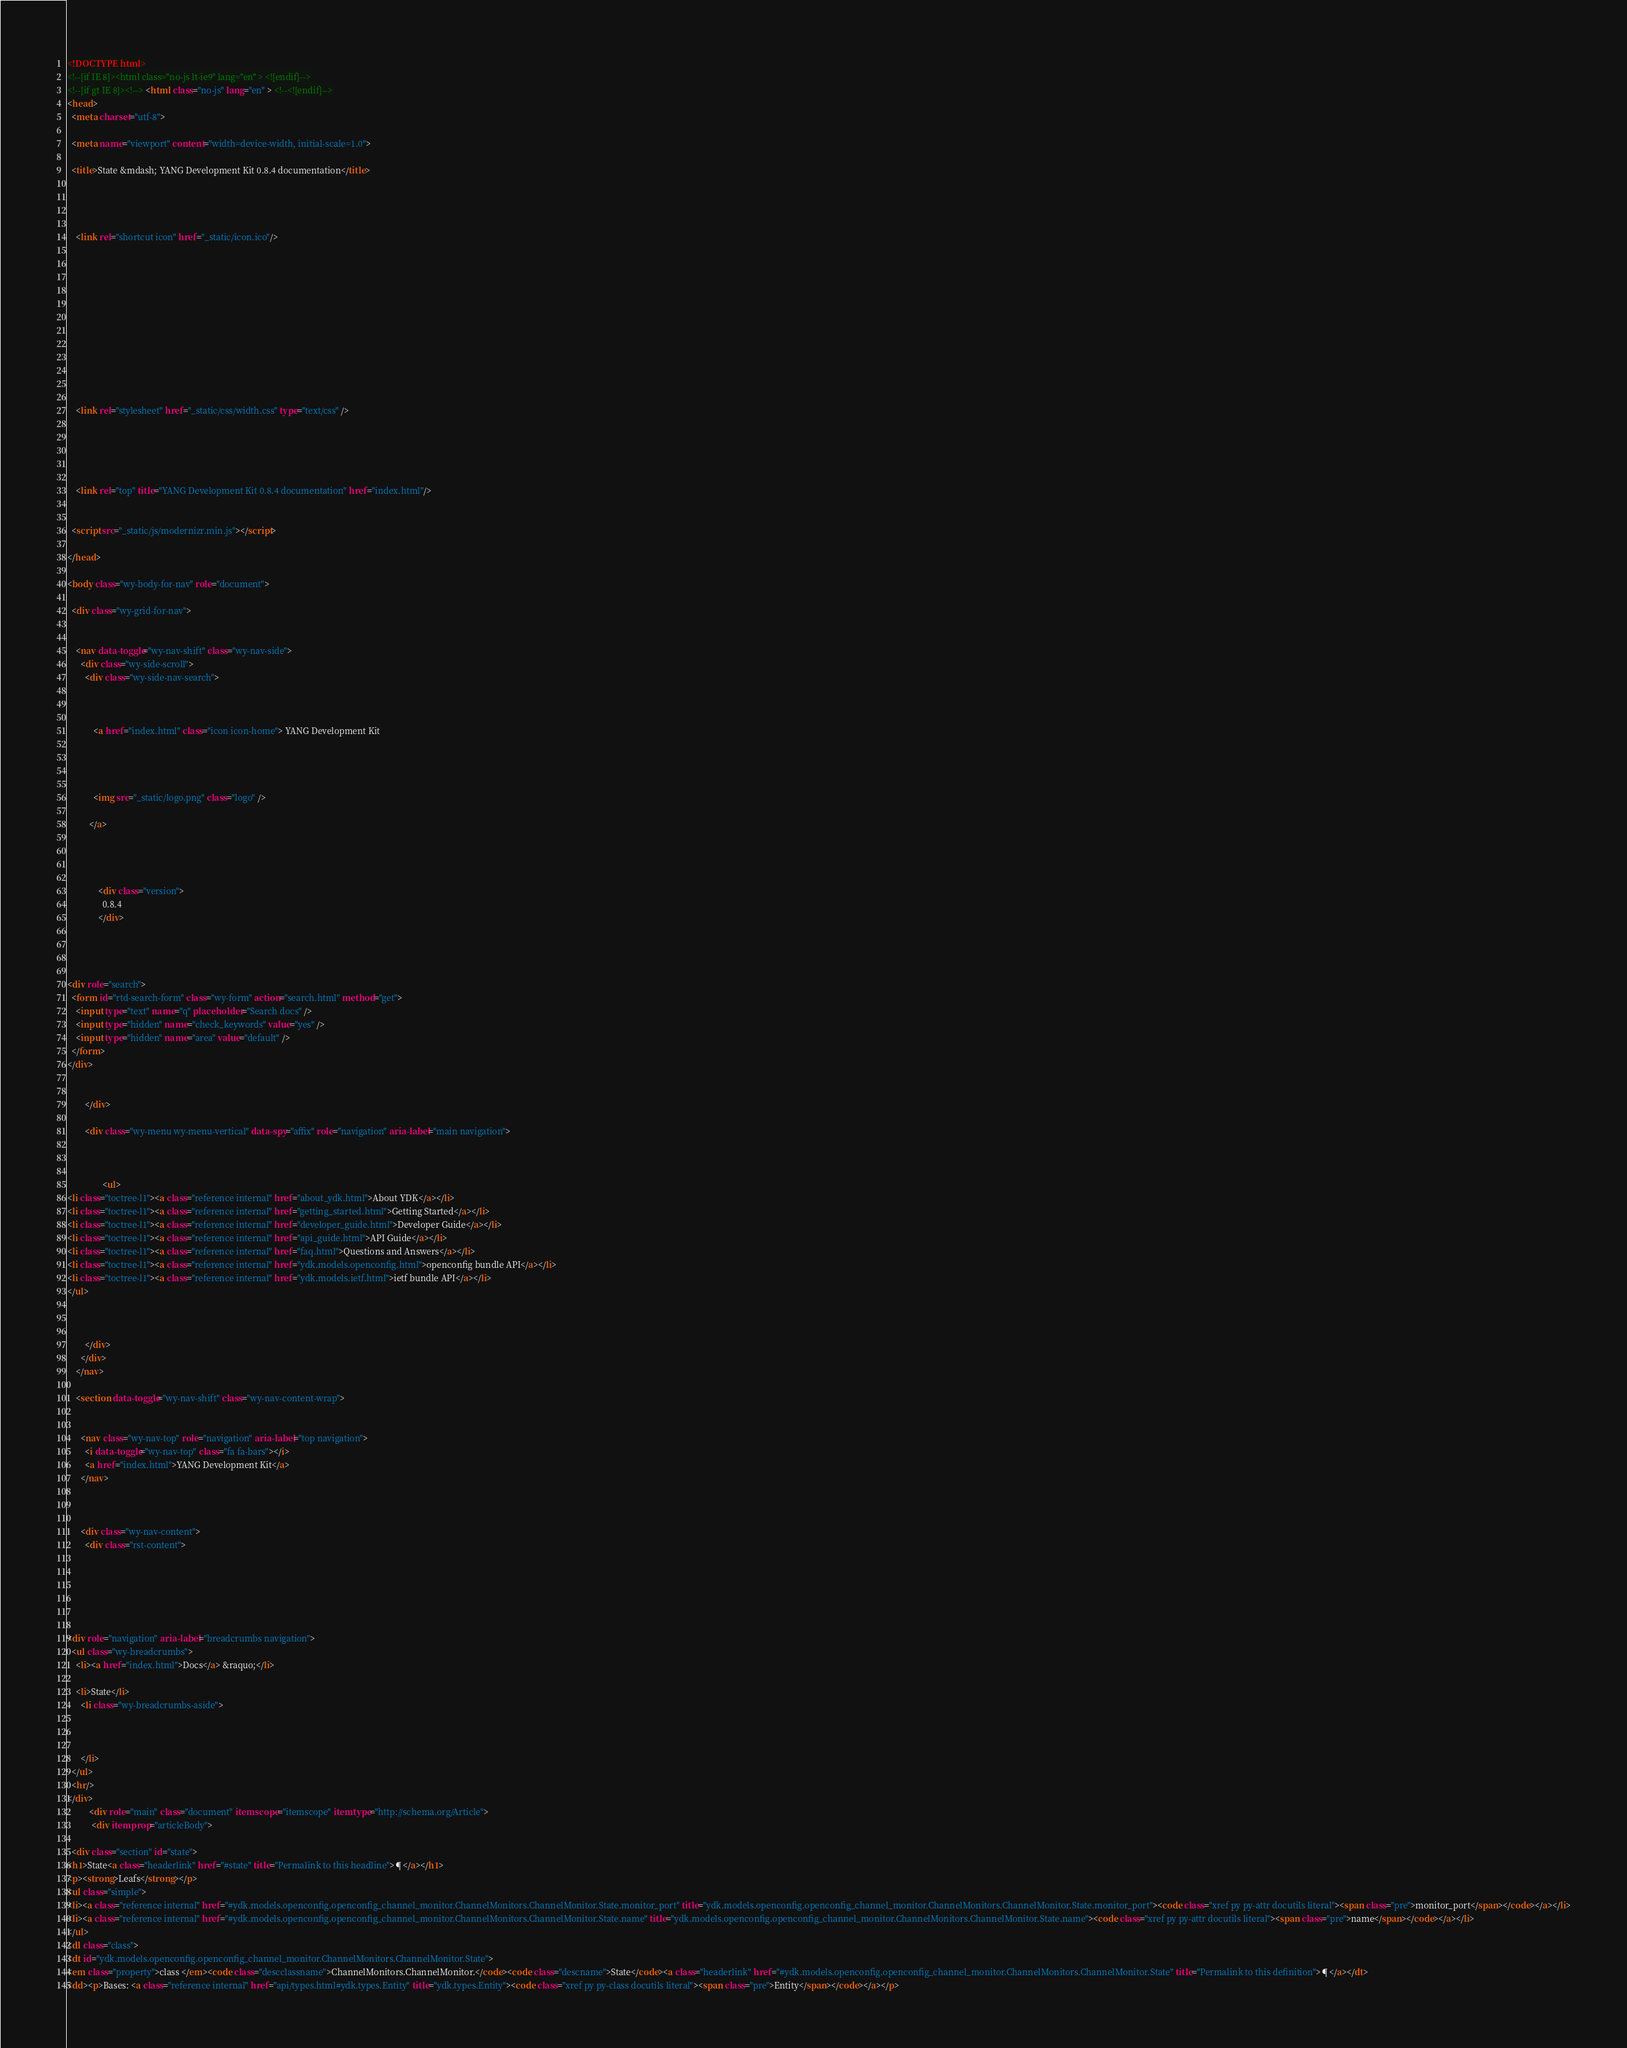Convert code to text. <code><loc_0><loc_0><loc_500><loc_500><_HTML_>

<!DOCTYPE html>
<!--[if IE 8]><html class="no-js lt-ie9" lang="en" > <![endif]-->
<!--[if gt IE 8]><!--> <html class="no-js" lang="en" > <!--<![endif]-->
<head>
  <meta charset="utf-8">
  
  <meta name="viewport" content="width=device-width, initial-scale=1.0">
  
  <title>State &mdash; YANG Development Kit 0.8.4 documentation</title>
  

  
  
    <link rel="shortcut icon" href="_static/icon.ico"/>
  

  

  
  
    

  

  
  
    <link rel="stylesheet" href="_static/css/width.css" type="text/css" />
  

  

  
    <link rel="top" title="YANG Development Kit 0.8.4 documentation" href="index.html"/> 

  
  <script src="_static/js/modernizr.min.js"></script>

</head>

<body class="wy-body-for-nav" role="document">

  <div class="wy-grid-for-nav">

    
    <nav data-toggle="wy-nav-shift" class="wy-nav-side">
      <div class="wy-side-scroll">
        <div class="wy-side-nav-search">
          

          
            <a href="index.html" class="icon icon-home"> YANG Development Kit
          

          
            
            <img src="_static/logo.png" class="logo" />
          
          </a>

          
            
            
              <div class="version">
                0.8.4
              </div>
            
          

          
<div role="search">
  <form id="rtd-search-form" class="wy-form" action="search.html" method="get">
    <input type="text" name="q" placeholder="Search docs" />
    <input type="hidden" name="check_keywords" value="yes" />
    <input type="hidden" name="area" value="default" />
  </form>
</div>

          
        </div>

        <div class="wy-menu wy-menu-vertical" data-spy="affix" role="navigation" aria-label="main navigation">
          
            
            
                <ul>
<li class="toctree-l1"><a class="reference internal" href="about_ydk.html">About YDK</a></li>
<li class="toctree-l1"><a class="reference internal" href="getting_started.html">Getting Started</a></li>
<li class="toctree-l1"><a class="reference internal" href="developer_guide.html">Developer Guide</a></li>
<li class="toctree-l1"><a class="reference internal" href="api_guide.html">API Guide</a></li>
<li class="toctree-l1"><a class="reference internal" href="faq.html">Questions and Answers</a></li>
<li class="toctree-l1"><a class="reference internal" href="ydk.models.openconfig.html">openconfig bundle API</a></li>
<li class="toctree-l1"><a class="reference internal" href="ydk.models.ietf.html">ietf bundle API</a></li>
</ul>

            
          
        </div>
      </div>
    </nav>

    <section data-toggle="wy-nav-shift" class="wy-nav-content-wrap">

      
      <nav class="wy-nav-top" role="navigation" aria-label="top navigation">
        <i data-toggle="wy-nav-top" class="fa fa-bars"></i>
        <a href="index.html">YANG Development Kit</a>
      </nav>


      
      <div class="wy-nav-content">
        <div class="rst-content">
          

 



<div role="navigation" aria-label="breadcrumbs navigation">
  <ul class="wy-breadcrumbs">
    <li><a href="index.html">Docs</a> &raquo;</li>
      
    <li>State</li>
      <li class="wy-breadcrumbs-aside">
        
          
        
      </li>
  </ul>
  <hr/>
</div>
          <div role="main" class="document" itemscope="itemscope" itemtype="http://schema.org/Article">
           <div itemprop="articleBody">
            
  <div class="section" id="state">
<h1>State<a class="headerlink" href="#state" title="Permalink to this headline">¶</a></h1>
<p><strong>Leafs</strong></p>
<ul class="simple">
<li><a class="reference internal" href="#ydk.models.openconfig.openconfig_channel_monitor.ChannelMonitors.ChannelMonitor.State.monitor_port" title="ydk.models.openconfig.openconfig_channel_monitor.ChannelMonitors.ChannelMonitor.State.monitor_port"><code class="xref py py-attr docutils literal"><span class="pre">monitor_port</span></code></a></li>
<li><a class="reference internal" href="#ydk.models.openconfig.openconfig_channel_monitor.ChannelMonitors.ChannelMonitor.State.name" title="ydk.models.openconfig.openconfig_channel_monitor.ChannelMonitors.ChannelMonitor.State.name"><code class="xref py py-attr docutils literal"><span class="pre">name</span></code></a></li>
</ul>
<dl class="class">
<dt id="ydk.models.openconfig.openconfig_channel_monitor.ChannelMonitors.ChannelMonitor.State">
<em class="property">class </em><code class="descclassname">ChannelMonitors.ChannelMonitor.</code><code class="descname">State</code><a class="headerlink" href="#ydk.models.openconfig.openconfig_channel_monitor.ChannelMonitors.ChannelMonitor.State" title="Permalink to this definition">¶</a></dt>
<dd><p>Bases: <a class="reference internal" href="api/types.html#ydk.types.Entity" title="ydk.types.Entity"><code class="xref py py-class docutils literal"><span class="pre">Entity</span></code></a></p></code> 